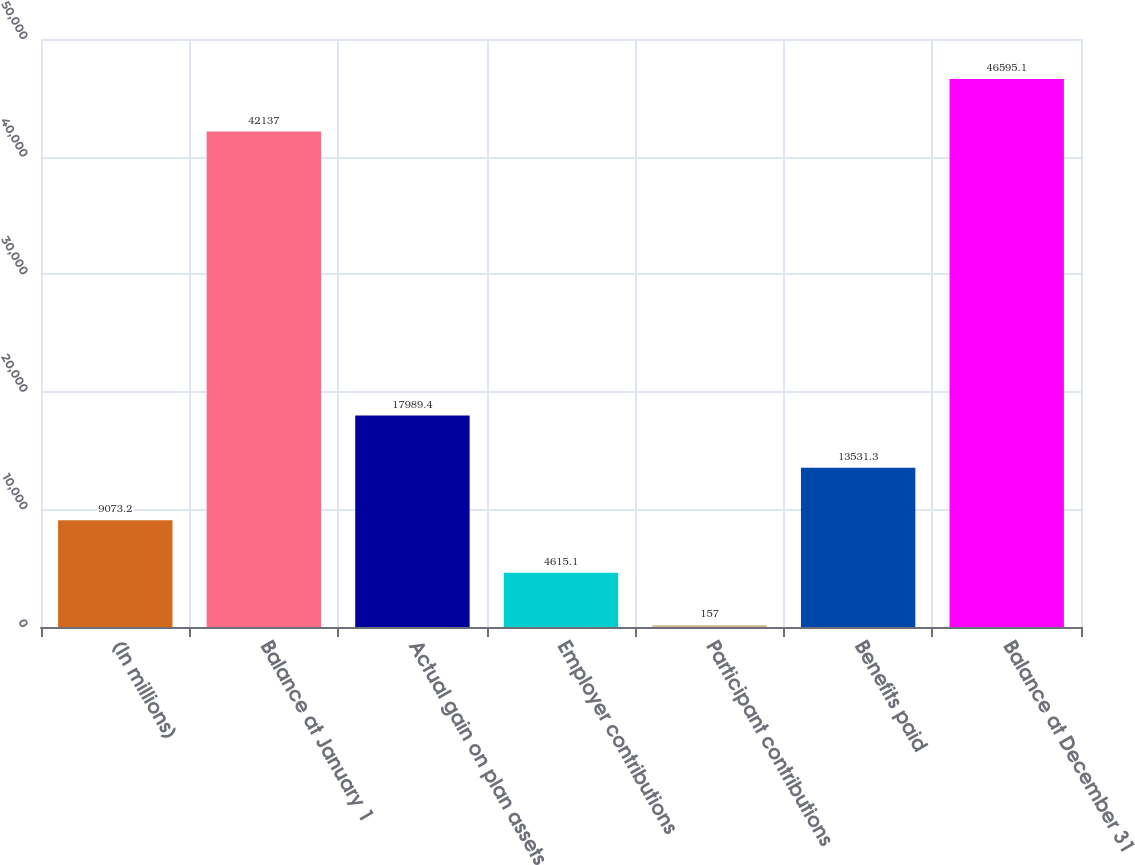<chart> <loc_0><loc_0><loc_500><loc_500><bar_chart><fcel>(In millions)<fcel>Balance at January 1<fcel>Actual gain on plan assets<fcel>Employer contributions<fcel>Participant contributions<fcel>Benefits paid<fcel>Balance at December 31<nl><fcel>9073.2<fcel>42137<fcel>17989.4<fcel>4615.1<fcel>157<fcel>13531.3<fcel>46595.1<nl></chart> 